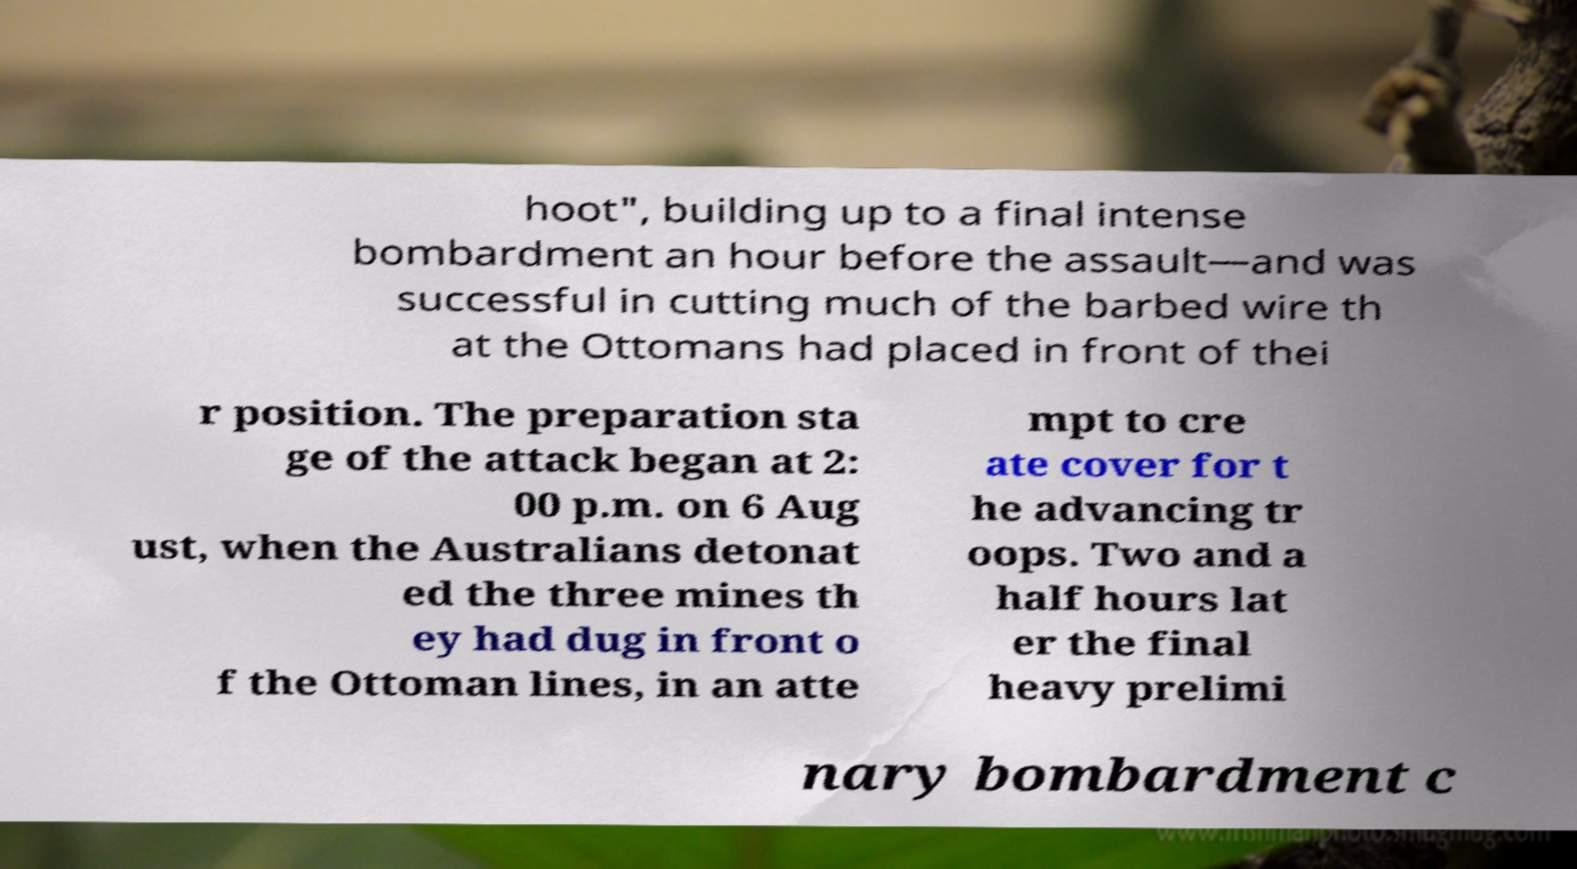Please read and relay the text visible in this image. What does it say? hoot", building up to a final intense bombardment an hour before the assault—and was successful in cutting much of the barbed wire th at the Ottomans had placed in front of thei r position. The preparation sta ge of the attack began at 2: 00 p.m. on 6 Aug ust, when the Australians detonat ed the three mines th ey had dug in front o f the Ottoman lines, in an atte mpt to cre ate cover for t he advancing tr oops. Two and a half hours lat er the final heavy prelimi nary bombardment c 